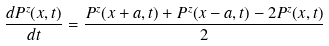Convert formula to latex. <formula><loc_0><loc_0><loc_500><loc_500>\frac { d P ^ { z } ( x , t ) } { d t } = \frac { P ^ { z } ( x + a , t ) + P ^ { z } ( x - a , t ) - 2 P ^ { z } ( x , t ) } { 2 }</formula> 